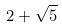<formula> <loc_0><loc_0><loc_500><loc_500>2 + \sqrt { 5 }</formula> 